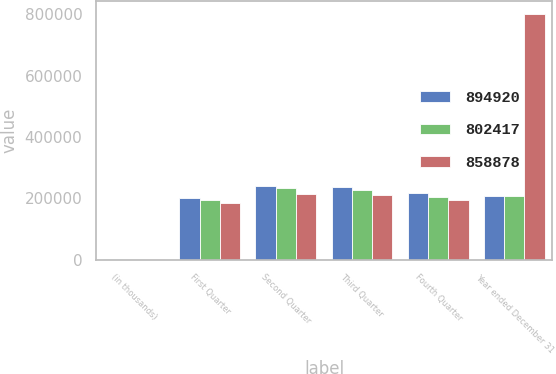Convert chart. <chart><loc_0><loc_0><loc_500><loc_500><stacked_bar_chart><ecel><fcel>(in thousands)<fcel>First Quarter<fcel>Second Quarter<fcel>Third Quarter<fcel>Fourth Quarter<fcel>Year ended December 31<nl><fcel>894920<fcel>2007<fcel>201232<fcel>239618<fcel>238116<fcel>215954<fcel>207000<nl><fcel>802417<fcel>2006<fcel>194187<fcel>232222<fcel>227816<fcel>204653<fcel>207000<nl><fcel>858878<fcel>2005<fcel>183915<fcel>214326<fcel>209346<fcel>194830<fcel>802417<nl></chart> 